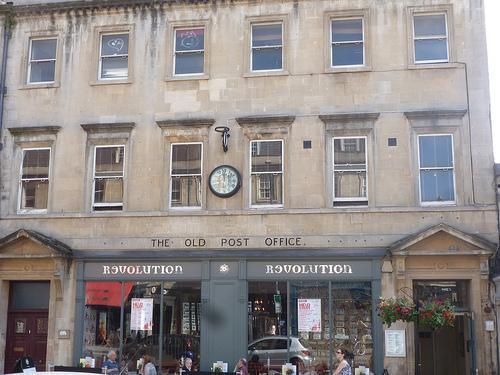How many doors are pictured?
Give a very brief answer. 2. How many people are sitting in front of the structure?
Give a very brief answer. 5. 